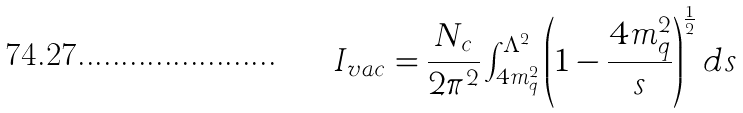Convert formula to latex. <formula><loc_0><loc_0><loc_500><loc_500>I _ { v a c } = \frac { N _ { c } } { 2 \pi ^ { 2 } } \int _ { 4 m _ { q } ^ { 2 } } ^ { \Lambda ^ { 2 } } \left ( 1 - \frac { 4 m _ { q } ^ { 2 } } { s } \right ) ^ { \frac { 1 } { 2 } } d s</formula> 